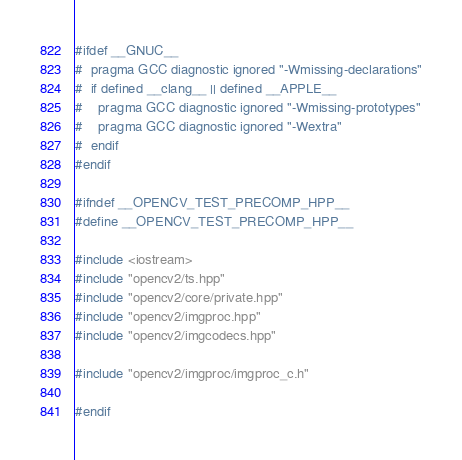Convert code to text. <code><loc_0><loc_0><loc_500><loc_500><_C++_>#ifdef __GNUC__
#  pragma GCC diagnostic ignored "-Wmissing-declarations"
#  if defined __clang__ || defined __APPLE__
#    pragma GCC diagnostic ignored "-Wmissing-prototypes"
#    pragma GCC diagnostic ignored "-Wextra"
#  endif
#endif

#ifndef __OPENCV_TEST_PRECOMP_HPP__
#define __OPENCV_TEST_PRECOMP_HPP__

#include <iostream>
#include "opencv2/ts.hpp"
#include "opencv2/core/private.hpp"
#include "opencv2/imgproc.hpp"
#include "opencv2/imgcodecs.hpp"

#include "opencv2/imgproc/imgproc_c.h"

#endif
</code> 